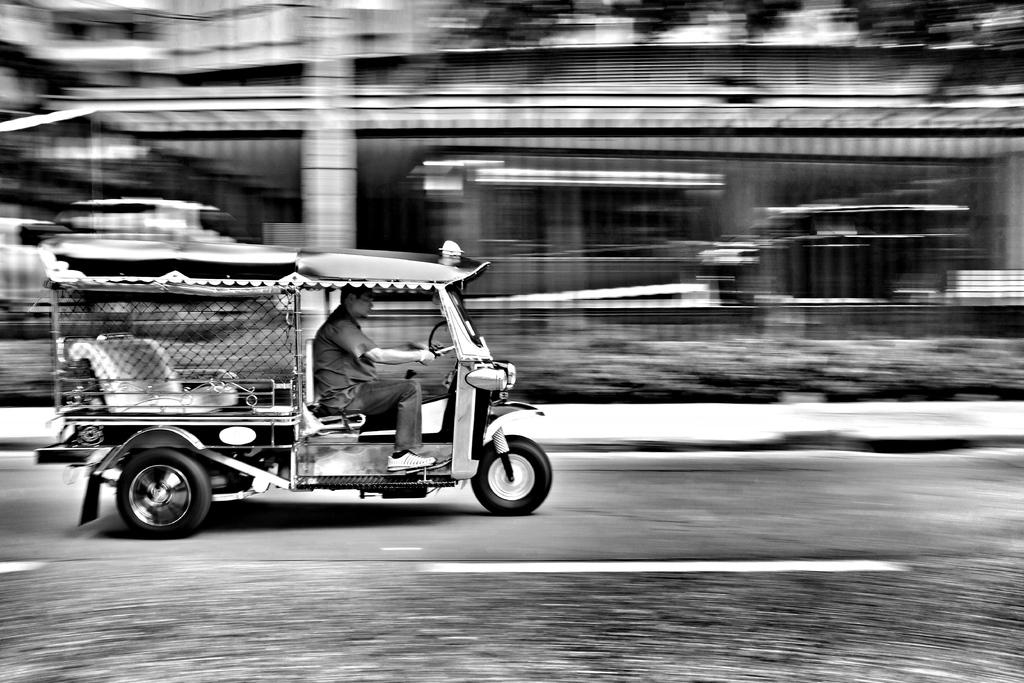What type of vehicle is in the image? There is a three-wheeler vehicle in the image. Who is inside the vehicle? A person is inside the vehicle. Where is the vehicle located? The vehicle is on the road. What can be seen in the background of the image? There is a building in the background of the image. Can you describe the other vehicles in the background? The other vehicles visible in the background are blurry. What type of snail can be seen racing with the three-wheeler vehicle in the image? There is no snail present in the image, and therefore no such race can be observed. 